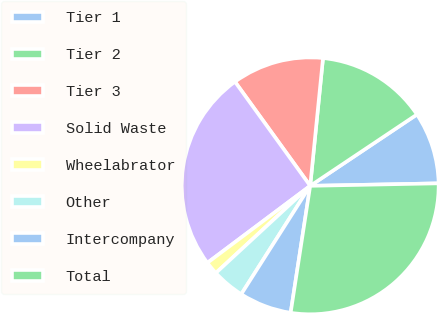Convert chart to OTSL. <chart><loc_0><loc_0><loc_500><loc_500><pie_chart><fcel>Tier 1<fcel>Tier 2<fcel>Tier 3<fcel>Solid Waste<fcel>Wheelabrator<fcel>Other<fcel>Intercompany<fcel>Total<nl><fcel>9.07%<fcel>14.03%<fcel>11.55%<fcel>25.27%<fcel>1.64%<fcel>4.11%<fcel>6.59%<fcel>27.74%<nl></chart> 